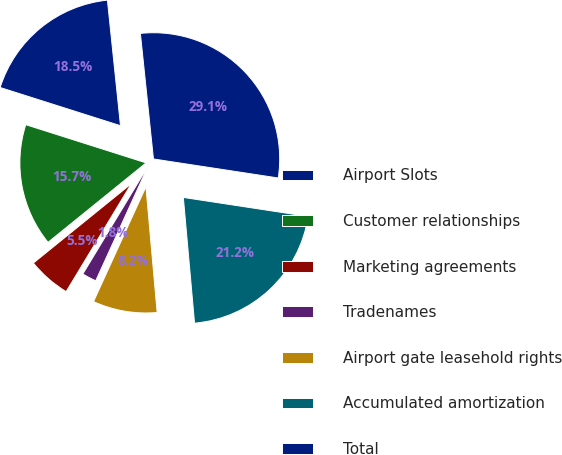<chart> <loc_0><loc_0><loc_500><loc_500><pie_chart><fcel>Airport Slots<fcel>Customer relationships<fcel>Marketing agreements<fcel>Tradenames<fcel>Airport gate leasehold rights<fcel>Accumulated amortization<fcel>Total<nl><fcel>18.46%<fcel>15.73%<fcel>5.51%<fcel>1.84%<fcel>8.23%<fcel>21.18%<fcel>29.06%<nl></chart> 